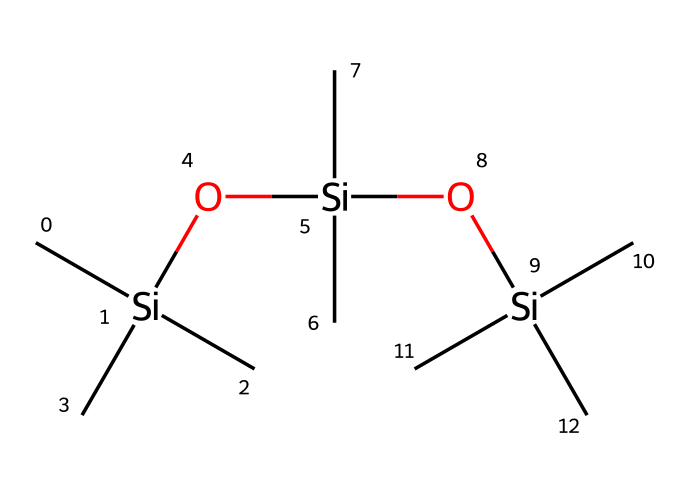What is the primary functional group present in this compound? The structure consists of multiple siloxane units, characterized by the silicon and oxygen atoms connected alternately. The presence of the Si-O bond indicates that the functional group is siloxane.
Answer: siloxane How many silicon atoms are in the compound? By analyzing the SMILES representation, we can count the occurrences of 'Si', which gives us the number of silicon atoms visible. There are three silicon atoms represented in the structure.
Answer: three What type of chemical interaction do siloxane compounds mainly exhibit? Siloxane compounds typically have strong covalent bonds primarily due to the Si-O linkages, indicating that they exhibit covalent interactions.
Answer: covalent How many methyl groups are present on the silicon atoms? Every silicon atom in the structure is bonded to three carbon atoms as indicated by the 'C' in the SMILES, implying there are a total of nine methyl groups from three silicon atoms, each having three methyl substituents.
Answer: nine What property do siloxane compounds provide to waterproof spray paint? Siloxane compounds are known for their hydrophobic properties, which contribute to the paint's water-repellent characteristics, allowing it to resist moisture and maintain durability.
Answer: water-repellent What is the degree of polymerization indicated in this molecule? The structure shows the repeating pattern of Si-O bonds along with numerous methyl groups, suggesting that it represents a linear polymer with multiple repeating siloxane units, indicating a degree of polymerization of three.
Answer: three 